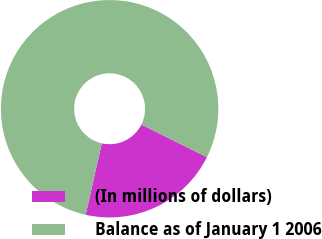Convert chart to OTSL. <chart><loc_0><loc_0><loc_500><loc_500><pie_chart><fcel>(In millions of dollars)<fcel>Balance as of January 1 2006<nl><fcel>21.19%<fcel>78.81%<nl></chart> 